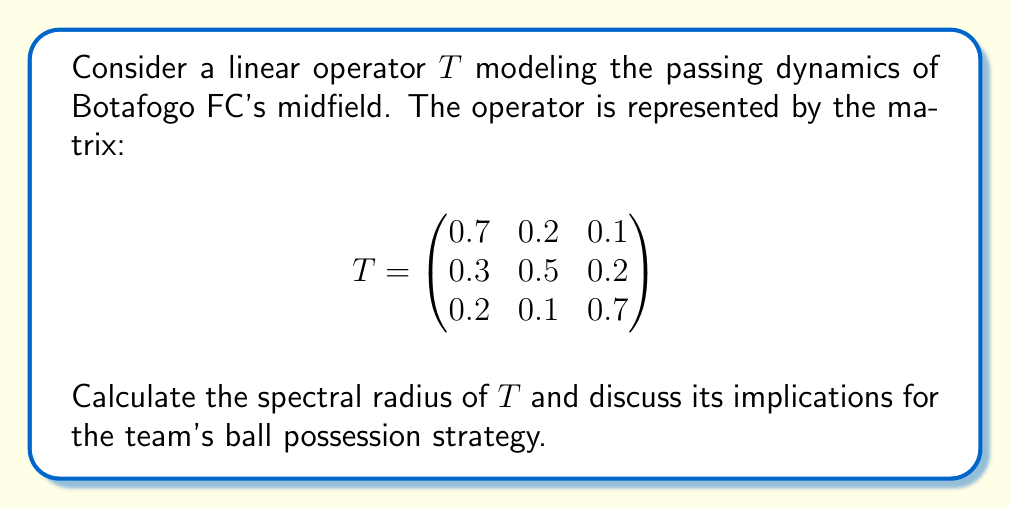Could you help me with this problem? To find the spectral radius of $T$, we need to follow these steps:

1) First, calculate the eigenvalues of $T$ by solving the characteristic equation:
   $$\det(T - \lambda I) = 0$$

2) Expand the determinant:
   $$\begin{vmatrix}
   0.7-\lambda & 0.2 & 0.1 \\
   0.3 & 0.5-\lambda & 0.2 \\
   0.2 & 0.1 & 0.7-\lambda
   \end{vmatrix} = 0$$

3) Solve the resulting cubic equation:
   $$-\lambda^3 + 1.9\lambda^2 - 0.97\lambda + 0.162 = 0$$

4) The roots of this equation are the eigenvalues. Using numerical methods, we find:
   $$\lambda_1 \approx 1, \lambda_2 \approx 0.5, \lambda_3 \approx 0.4$$

5) The spectral radius $\rho(T)$ is the maximum absolute value of the eigenvalues:
   $$\rho(T) = \max\{|\lambda_1|, |\lambda_2|, |\lambda_3|\} = 1$$

6) Interpretation: The spectral radius of 1 indicates that the passing dynamics are stable. In the context of Botafogo FC's midfield, this suggests that the team's ball possession strategy is balanced and sustainable over time. The dominant eigenvalue of 1 implies that the overall passing pattern remains consistent, which could be beneficial for maintaining control during matches in Campeonato Brasileiro Série B.
Answer: $\rho(T) = 1$ 